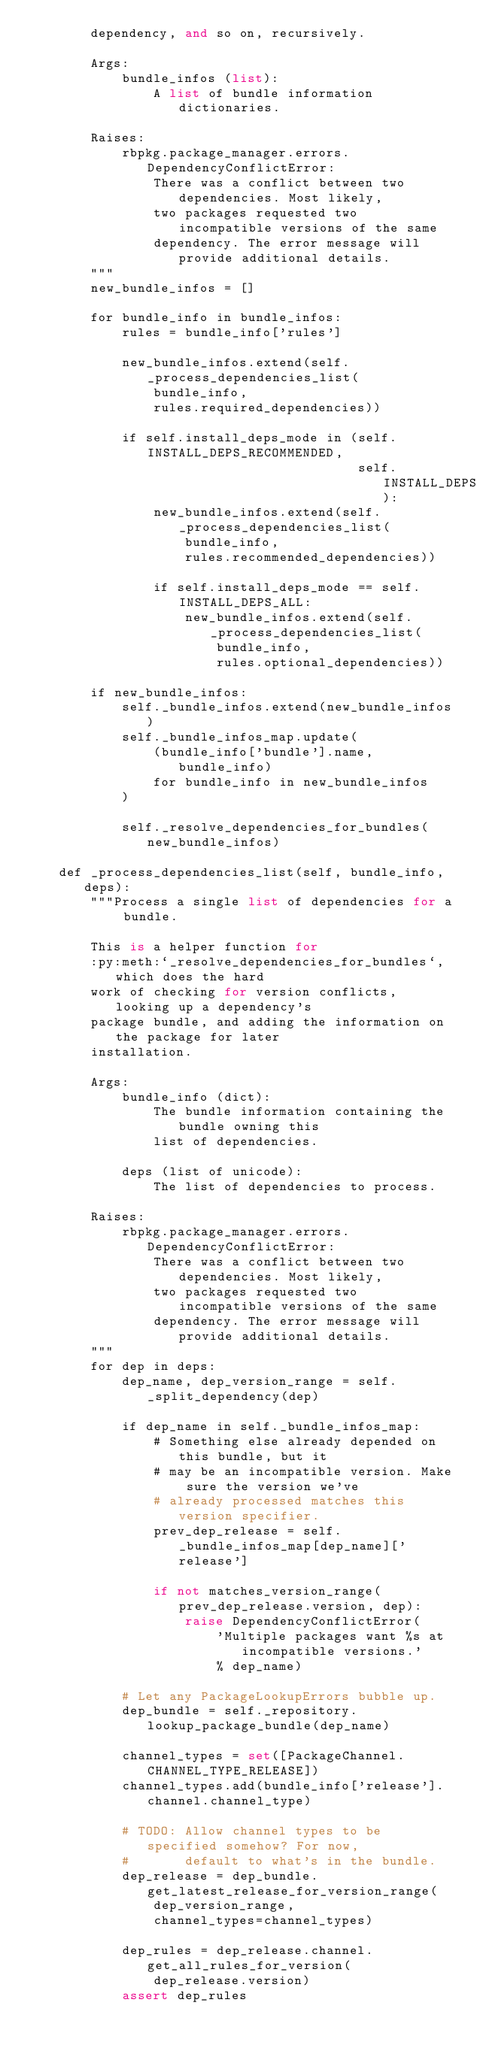Convert code to text. <code><loc_0><loc_0><loc_500><loc_500><_Python_>        dependency, and so on, recursively.

        Args:
            bundle_infos (list):
                A list of bundle information dictionaries.

        Raises:
            rbpkg.package_manager.errors.DependencyConflictError:
                There was a conflict between two dependencies. Most likely,
                two packages requested two incompatible versions of the same
                dependency. The error message will provide additional details.
        """
        new_bundle_infos = []

        for bundle_info in bundle_infos:
            rules = bundle_info['rules']

            new_bundle_infos.extend(self._process_dependencies_list(
                bundle_info,
                rules.required_dependencies))

            if self.install_deps_mode in (self.INSTALL_DEPS_RECOMMENDED,
                                          self.INSTALL_DEPS_ALL):
                new_bundle_infos.extend(self._process_dependencies_list(
                    bundle_info,
                    rules.recommended_dependencies))

                if self.install_deps_mode == self.INSTALL_DEPS_ALL:
                    new_bundle_infos.extend(self._process_dependencies_list(
                        bundle_info,
                        rules.optional_dependencies))

        if new_bundle_infos:
            self._bundle_infos.extend(new_bundle_infos)
            self._bundle_infos_map.update(
                (bundle_info['bundle'].name, bundle_info)
                for bundle_info in new_bundle_infos
            )

            self._resolve_dependencies_for_bundles(new_bundle_infos)

    def _process_dependencies_list(self, bundle_info, deps):
        """Process a single list of dependencies for a bundle.

        This is a helper function for
        :py:meth:`_resolve_dependencies_for_bundles`, which does the hard
        work of checking for version conflicts, looking up a dependency's
        package bundle, and adding the information on the package for later
        installation.

        Args:
            bundle_info (dict):
                The bundle information containing the bundle owning this
                list of dependencies.

            deps (list of unicode):
                The list of dependencies to process.

        Raises:
            rbpkg.package_manager.errors.DependencyConflictError:
                There was a conflict between two dependencies. Most likely,
                two packages requested two incompatible versions of the same
                dependency. The error message will provide additional details.
        """
        for dep in deps:
            dep_name, dep_version_range = self._split_dependency(dep)

            if dep_name in self._bundle_infos_map:
                # Something else already depended on this bundle, but it
                # may be an incompatible version. Make sure the version we've
                # already processed matches this version specifier.
                prev_dep_release = self._bundle_infos_map[dep_name]['release']

                if not matches_version_range(prev_dep_release.version, dep):
                    raise DependencyConflictError(
                        'Multiple packages want %s at incompatible versions.'
                        % dep_name)

            # Let any PackageLookupErrors bubble up.
            dep_bundle = self._repository.lookup_package_bundle(dep_name)

            channel_types = set([PackageChannel.CHANNEL_TYPE_RELEASE])
            channel_types.add(bundle_info['release'].channel.channel_type)

            # TODO: Allow channel types to be specified somehow? For now,
            #       default to what's in the bundle.
            dep_release = dep_bundle.get_latest_release_for_version_range(
                dep_version_range,
                channel_types=channel_types)

            dep_rules = dep_release.channel.get_all_rules_for_version(
                dep_release.version)
            assert dep_rules
</code> 